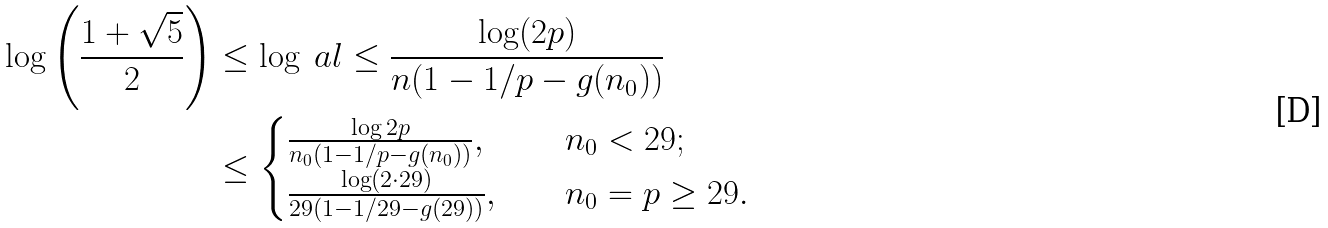<formula> <loc_0><loc_0><loc_500><loc_500>\log \left ( \frac { 1 + \sqrt { 5 } } { 2 } \right ) & \leq \log \ a l \leq \frac { \log ( 2 p ) } { n ( 1 - { 1 } / { p } - g ( n _ { 0 } ) ) } \\ & \leq \begin{cases} \frac { \log 2 p } { n _ { 0 } ( 1 - { 1 } / { p } - g ( n _ { 0 } ) ) } , & \quad n _ { 0 } < 2 9 ; \\ \frac { \log ( 2 \cdot 2 9 ) } { 2 9 ( 1 - { 1 } / { 2 9 } - g ( 2 9 ) ) } , & \quad n _ { 0 } = p \geq 2 9 . \end{cases}</formula> 